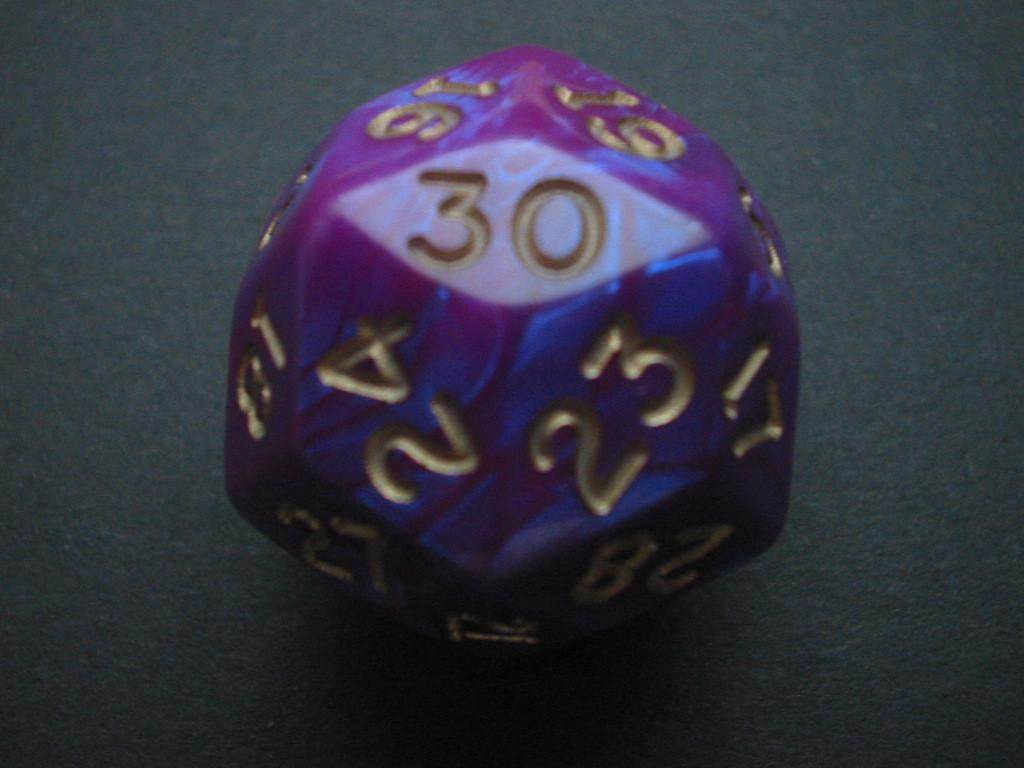What objects are present in the image? There are dice in the image. What can be seen on the surfaces of the dice? The dice have numbers on their surfaces. What type of toothpaste is being distributed in the image? There is no toothpaste present in the image. What is being used to carry the dice in the image? The image does not show any baskets or containers for carrying the dice. 